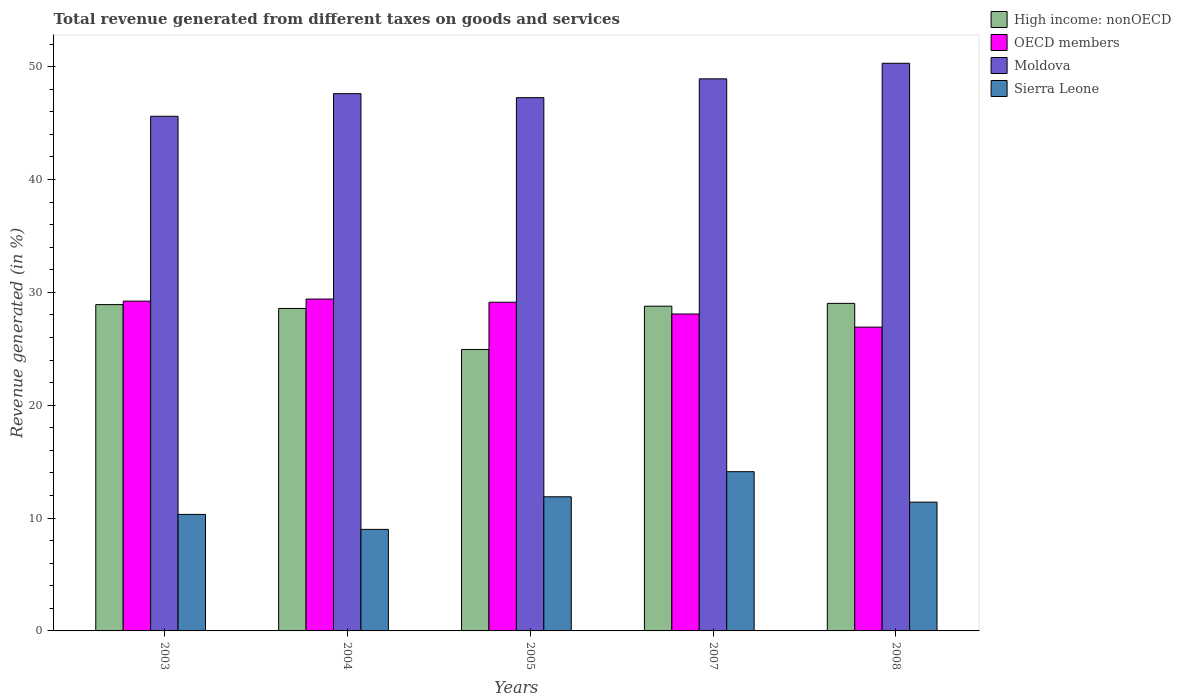How many different coloured bars are there?
Offer a terse response. 4. How many groups of bars are there?
Give a very brief answer. 5. Are the number of bars per tick equal to the number of legend labels?
Provide a short and direct response. Yes. Are the number of bars on each tick of the X-axis equal?
Offer a terse response. Yes. How many bars are there on the 2nd tick from the left?
Provide a succinct answer. 4. How many bars are there on the 2nd tick from the right?
Your answer should be very brief. 4. What is the label of the 3rd group of bars from the left?
Ensure brevity in your answer.  2005. What is the total revenue generated in OECD members in 2003?
Offer a terse response. 29.22. Across all years, what is the maximum total revenue generated in Sierra Leone?
Your answer should be compact. 14.11. Across all years, what is the minimum total revenue generated in Moldova?
Ensure brevity in your answer.  45.61. In which year was the total revenue generated in High income: nonOECD maximum?
Offer a very short reply. 2008. What is the total total revenue generated in Sierra Leone in the graph?
Offer a very short reply. 56.73. What is the difference between the total revenue generated in Moldova in 2005 and that in 2008?
Provide a short and direct response. -3.05. What is the difference between the total revenue generated in Moldova in 2007 and the total revenue generated in Sierra Leone in 2004?
Provide a succinct answer. 39.93. What is the average total revenue generated in OECD members per year?
Ensure brevity in your answer.  28.55. In the year 2003, what is the difference between the total revenue generated in OECD members and total revenue generated in Sierra Leone?
Give a very brief answer. 18.9. In how many years, is the total revenue generated in High income: nonOECD greater than 30 %?
Your response must be concise. 0. What is the ratio of the total revenue generated in Sierra Leone in 2003 to that in 2007?
Provide a short and direct response. 0.73. Is the difference between the total revenue generated in OECD members in 2005 and 2007 greater than the difference between the total revenue generated in Sierra Leone in 2005 and 2007?
Offer a terse response. Yes. What is the difference between the highest and the second highest total revenue generated in Moldova?
Provide a short and direct response. 1.38. What is the difference between the highest and the lowest total revenue generated in High income: nonOECD?
Provide a succinct answer. 4.09. In how many years, is the total revenue generated in OECD members greater than the average total revenue generated in OECD members taken over all years?
Provide a succinct answer. 3. Is it the case that in every year, the sum of the total revenue generated in OECD members and total revenue generated in Moldova is greater than the sum of total revenue generated in Sierra Leone and total revenue generated in High income: nonOECD?
Make the answer very short. Yes. What does the 1st bar from the left in 2005 represents?
Keep it short and to the point. High income: nonOECD. How many bars are there?
Ensure brevity in your answer.  20. Are the values on the major ticks of Y-axis written in scientific E-notation?
Your answer should be very brief. No. Does the graph contain any zero values?
Offer a very short reply. No. How many legend labels are there?
Give a very brief answer. 4. How are the legend labels stacked?
Provide a succinct answer. Vertical. What is the title of the graph?
Your answer should be very brief. Total revenue generated from different taxes on goods and services. Does "Afghanistan" appear as one of the legend labels in the graph?
Your answer should be very brief. No. What is the label or title of the X-axis?
Keep it short and to the point. Years. What is the label or title of the Y-axis?
Your answer should be compact. Revenue generated (in %). What is the Revenue generated (in %) of High income: nonOECD in 2003?
Keep it short and to the point. 28.92. What is the Revenue generated (in %) in OECD members in 2003?
Your answer should be very brief. 29.22. What is the Revenue generated (in %) of Moldova in 2003?
Provide a succinct answer. 45.61. What is the Revenue generated (in %) of Sierra Leone in 2003?
Your answer should be very brief. 10.32. What is the Revenue generated (in %) in High income: nonOECD in 2004?
Provide a succinct answer. 28.58. What is the Revenue generated (in %) of OECD members in 2004?
Ensure brevity in your answer.  29.41. What is the Revenue generated (in %) in Moldova in 2004?
Ensure brevity in your answer.  47.61. What is the Revenue generated (in %) of Sierra Leone in 2004?
Provide a short and direct response. 9. What is the Revenue generated (in %) in High income: nonOECD in 2005?
Ensure brevity in your answer.  24.94. What is the Revenue generated (in %) in OECD members in 2005?
Your answer should be very brief. 29.13. What is the Revenue generated (in %) of Moldova in 2005?
Your answer should be compact. 47.26. What is the Revenue generated (in %) of Sierra Leone in 2005?
Provide a succinct answer. 11.89. What is the Revenue generated (in %) of High income: nonOECD in 2007?
Give a very brief answer. 28.78. What is the Revenue generated (in %) of OECD members in 2007?
Provide a succinct answer. 28.08. What is the Revenue generated (in %) in Moldova in 2007?
Provide a short and direct response. 48.92. What is the Revenue generated (in %) in Sierra Leone in 2007?
Offer a terse response. 14.11. What is the Revenue generated (in %) in High income: nonOECD in 2008?
Offer a terse response. 29.03. What is the Revenue generated (in %) of OECD members in 2008?
Provide a succinct answer. 26.92. What is the Revenue generated (in %) of Moldova in 2008?
Provide a succinct answer. 50.3. What is the Revenue generated (in %) of Sierra Leone in 2008?
Give a very brief answer. 11.41. Across all years, what is the maximum Revenue generated (in %) in High income: nonOECD?
Make the answer very short. 29.03. Across all years, what is the maximum Revenue generated (in %) of OECD members?
Provide a succinct answer. 29.41. Across all years, what is the maximum Revenue generated (in %) of Moldova?
Ensure brevity in your answer.  50.3. Across all years, what is the maximum Revenue generated (in %) of Sierra Leone?
Your answer should be compact. 14.11. Across all years, what is the minimum Revenue generated (in %) in High income: nonOECD?
Give a very brief answer. 24.94. Across all years, what is the minimum Revenue generated (in %) in OECD members?
Provide a succinct answer. 26.92. Across all years, what is the minimum Revenue generated (in %) in Moldova?
Provide a short and direct response. 45.61. Across all years, what is the minimum Revenue generated (in %) of Sierra Leone?
Provide a succinct answer. 9. What is the total Revenue generated (in %) in High income: nonOECD in the graph?
Your answer should be compact. 140.24. What is the total Revenue generated (in %) of OECD members in the graph?
Your answer should be very brief. 142.76. What is the total Revenue generated (in %) of Moldova in the graph?
Give a very brief answer. 239.69. What is the total Revenue generated (in %) in Sierra Leone in the graph?
Your answer should be compact. 56.73. What is the difference between the Revenue generated (in %) in High income: nonOECD in 2003 and that in 2004?
Your answer should be compact. 0.34. What is the difference between the Revenue generated (in %) of OECD members in 2003 and that in 2004?
Offer a very short reply. -0.18. What is the difference between the Revenue generated (in %) of Moldova in 2003 and that in 2004?
Provide a succinct answer. -2. What is the difference between the Revenue generated (in %) of Sierra Leone in 2003 and that in 2004?
Keep it short and to the point. 1.33. What is the difference between the Revenue generated (in %) in High income: nonOECD in 2003 and that in 2005?
Your answer should be very brief. 3.98. What is the difference between the Revenue generated (in %) of OECD members in 2003 and that in 2005?
Offer a very short reply. 0.1. What is the difference between the Revenue generated (in %) in Moldova in 2003 and that in 2005?
Your response must be concise. -1.65. What is the difference between the Revenue generated (in %) of Sierra Leone in 2003 and that in 2005?
Ensure brevity in your answer.  -1.56. What is the difference between the Revenue generated (in %) in High income: nonOECD in 2003 and that in 2007?
Keep it short and to the point. 0.14. What is the difference between the Revenue generated (in %) in OECD members in 2003 and that in 2007?
Offer a terse response. 1.14. What is the difference between the Revenue generated (in %) of Moldova in 2003 and that in 2007?
Give a very brief answer. -3.32. What is the difference between the Revenue generated (in %) of Sierra Leone in 2003 and that in 2007?
Ensure brevity in your answer.  -3.79. What is the difference between the Revenue generated (in %) of High income: nonOECD in 2003 and that in 2008?
Your response must be concise. -0.11. What is the difference between the Revenue generated (in %) of OECD members in 2003 and that in 2008?
Offer a very short reply. 2.3. What is the difference between the Revenue generated (in %) of Moldova in 2003 and that in 2008?
Ensure brevity in your answer.  -4.7. What is the difference between the Revenue generated (in %) of Sierra Leone in 2003 and that in 2008?
Make the answer very short. -1.09. What is the difference between the Revenue generated (in %) of High income: nonOECD in 2004 and that in 2005?
Your response must be concise. 3.63. What is the difference between the Revenue generated (in %) of OECD members in 2004 and that in 2005?
Keep it short and to the point. 0.28. What is the difference between the Revenue generated (in %) in Moldova in 2004 and that in 2005?
Make the answer very short. 0.35. What is the difference between the Revenue generated (in %) of Sierra Leone in 2004 and that in 2005?
Your answer should be compact. -2.89. What is the difference between the Revenue generated (in %) in High income: nonOECD in 2004 and that in 2007?
Provide a succinct answer. -0.2. What is the difference between the Revenue generated (in %) of OECD members in 2004 and that in 2007?
Offer a terse response. 1.32. What is the difference between the Revenue generated (in %) of Moldova in 2004 and that in 2007?
Ensure brevity in your answer.  -1.31. What is the difference between the Revenue generated (in %) in Sierra Leone in 2004 and that in 2007?
Provide a succinct answer. -5.11. What is the difference between the Revenue generated (in %) in High income: nonOECD in 2004 and that in 2008?
Give a very brief answer. -0.45. What is the difference between the Revenue generated (in %) of OECD members in 2004 and that in 2008?
Offer a very short reply. 2.49. What is the difference between the Revenue generated (in %) in Moldova in 2004 and that in 2008?
Offer a very short reply. -2.69. What is the difference between the Revenue generated (in %) of Sierra Leone in 2004 and that in 2008?
Your answer should be compact. -2.41. What is the difference between the Revenue generated (in %) in High income: nonOECD in 2005 and that in 2007?
Offer a terse response. -3.84. What is the difference between the Revenue generated (in %) of OECD members in 2005 and that in 2007?
Your response must be concise. 1.04. What is the difference between the Revenue generated (in %) of Moldova in 2005 and that in 2007?
Your response must be concise. -1.67. What is the difference between the Revenue generated (in %) in Sierra Leone in 2005 and that in 2007?
Give a very brief answer. -2.23. What is the difference between the Revenue generated (in %) of High income: nonOECD in 2005 and that in 2008?
Offer a terse response. -4.09. What is the difference between the Revenue generated (in %) in OECD members in 2005 and that in 2008?
Give a very brief answer. 2.2. What is the difference between the Revenue generated (in %) of Moldova in 2005 and that in 2008?
Give a very brief answer. -3.05. What is the difference between the Revenue generated (in %) of Sierra Leone in 2005 and that in 2008?
Offer a terse response. 0.48. What is the difference between the Revenue generated (in %) in High income: nonOECD in 2007 and that in 2008?
Offer a terse response. -0.25. What is the difference between the Revenue generated (in %) of OECD members in 2007 and that in 2008?
Make the answer very short. 1.16. What is the difference between the Revenue generated (in %) of Moldova in 2007 and that in 2008?
Offer a very short reply. -1.38. What is the difference between the Revenue generated (in %) of Sierra Leone in 2007 and that in 2008?
Provide a succinct answer. 2.7. What is the difference between the Revenue generated (in %) in High income: nonOECD in 2003 and the Revenue generated (in %) in OECD members in 2004?
Offer a terse response. -0.49. What is the difference between the Revenue generated (in %) of High income: nonOECD in 2003 and the Revenue generated (in %) of Moldova in 2004?
Ensure brevity in your answer.  -18.69. What is the difference between the Revenue generated (in %) in High income: nonOECD in 2003 and the Revenue generated (in %) in Sierra Leone in 2004?
Offer a terse response. 19.92. What is the difference between the Revenue generated (in %) in OECD members in 2003 and the Revenue generated (in %) in Moldova in 2004?
Give a very brief answer. -18.39. What is the difference between the Revenue generated (in %) in OECD members in 2003 and the Revenue generated (in %) in Sierra Leone in 2004?
Ensure brevity in your answer.  20.23. What is the difference between the Revenue generated (in %) of Moldova in 2003 and the Revenue generated (in %) of Sierra Leone in 2004?
Give a very brief answer. 36.61. What is the difference between the Revenue generated (in %) in High income: nonOECD in 2003 and the Revenue generated (in %) in OECD members in 2005?
Your answer should be compact. -0.21. What is the difference between the Revenue generated (in %) of High income: nonOECD in 2003 and the Revenue generated (in %) of Moldova in 2005?
Ensure brevity in your answer.  -18.34. What is the difference between the Revenue generated (in %) in High income: nonOECD in 2003 and the Revenue generated (in %) in Sierra Leone in 2005?
Provide a short and direct response. 17.03. What is the difference between the Revenue generated (in %) in OECD members in 2003 and the Revenue generated (in %) in Moldova in 2005?
Your answer should be compact. -18.03. What is the difference between the Revenue generated (in %) of OECD members in 2003 and the Revenue generated (in %) of Sierra Leone in 2005?
Keep it short and to the point. 17.34. What is the difference between the Revenue generated (in %) of Moldova in 2003 and the Revenue generated (in %) of Sierra Leone in 2005?
Keep it short and to the point. 33.72. What is the difference between the Revenue generated (in %) of High income: nonOECD in 2003 and the Revenue generated (in %) of OECD members in 2007?
Provide a succinct answer. 0.83. What is the difference between the Revenue generated (in %) in High income: nonOECD in 2003 and the Revenue generated (in %) in Moldova in 2007?
Keep it short and to the point. -20.01. What is the difference between the Revenue generated (in %) in High income: nonOECD in 2003 and the Revenue generated (in %) in Sierra Leone in 2007?
Your answer should be compact. 14.81. What is the difference between the Revenue generated (in %) in OECD members in 2003 and the Revenue generated (in %) in Moldova in 2007?
Keep it short and to the point. -19.7. What is the difference between the Revenue generated (in %) of OECD members in 2003 and the Revenue generated (in %) of Sierra Leone in 2007?
Give a very brief answer. 15.11. What is the difference between the Revenue generated (in %) of Moldova in 2003 and the Revenue generated (in %) of Sierra Leone in 2007?
Keep it short and to the point. 31.49. What is the difference between the Revenue generated (in %) in High income: nonOECD in 2003 and the Revenue generated (in %) in OECD members in 2008?
Your response must be concise. 1.99. What is the difference between the Revenue generated (in %) of High income: nonOECD in 2003 and the Revenue generated (in %) of Moldova in 2008?
Your answer should be very brief. -21.39. What is the difference between the Revenue generated (in %) in High income: nonOECD in 2003 and the Revenue generated (in %) in Sierra Leone in 2008?
Provide a succinct answer. 17.51. What is the difference between the Revenue generated (in %) in OECD members in 2003 and the Revenue generated (in %) in Moldova in 2008?
Offer a very short reply. -21.08. What is the difference between the Revenue generated (in %) in OECD members in 2003 and the Revenue generated (in %) in Sierra Leone in 2008?
Provide a short and direct response. 17.81. What is the difference between the Revenue generated (in %) in Moldova in 2003 and the Revenue generated (in %) in Sierra Leone in 2008?
Your answer should be very brief. 34.19. What is the difference between the Revenue generated (in %) in High income: nonOECD in 2004 and the Revenue generated (in %) in OECD members in 2005?
Ensure brevity in your answer.  -0.55. What is the difference between the Revenue generated (in %) of High income: nonOECD in 2004 and the Revenue generated (in %) of Moldova in 2005?
Provide a short and direct response. -18.68. What is the difference between the Revenue generated (in %) of High income: nonOECD in 2004 and the Revenue generated (in %) of Sierra Leone in 2005?
Provide a succinct answer. 16.69. What is the difference between the Revenue generated (in %) in OECD members in 2004 and the Revenue generated (in %) in Moldova in 2005?
Your response must be concise. -17.85. What is the difference between the Revenue generated (in %) in OECD members in 2004 and the Revenue generated (in %) in Sierra Leone in 2005?
Keep it short and to the point. 17.52. What is the difference between the Revenue generated (in %) of Moldova in 2004 and the Revenue generated (in %) of Sierra Leone in 2005?
Give a very brief answer. 35.72. What is the difference between the Revenue generated (in %) in High income: nonOECD in 2004 and the Revenue generated (in %) in OECD members in 2007?
Provide a succinct answer. 0.49. What is the difference between the Revenue generated (in %) of High income: nonOECD in 2004 and the Revenue generated (in %) of Moldova in 2007?
Offer a very short reply. -20.35. What is the difference between the Revenue generated (in %) of High income: nonOECD in 2004 and the Revenue generated (in %) of Sierra Leone in 2007?
Your answer should be very brief. 14.46. What is the difference between the Revenue generated (in %) of OECD members in 2004 and the Revenue generated (in %) of Moldova in 2007?
Your answer should be very brief. -19.51. What is the difference between the Revenue generated (in %) of OECD members in 2004 and the Revenue generated (in %) of Sierra Leone in 2007?
Make the answer very short. 15.3. What is the difference between the Revenue generated (in %) in Moldova in 2004 and the Revenue generated (in %) in Sierra Leone in 2007?
Your answer should be compact. 33.5. What is the difference between the Revenue generated (in %) of High income: nonOECD in 2004 and the Revenue generated (in %) of OECD members in 2008?
Ensure brevity in your answer.  1.65. What is the difference between the Revenue generated (in %) of High income: nonOECD in 2004 and the Revenue generated (in %) of Moldova in 2008?
Offer a very short reply. -21.73. What is the difference between the Revenue generated (in %) of High income: nonOECD in 2004 and the Revenue generated (in %) of Sierra Leone in 2008?
Make the answer very short. 17.17. What is the difference between the Revenue generated (in %) of OECD members in 2004 and the Revenue generated (in %) of Moldova in 2008?
Make the answer very short. -20.89. What is the difference between the Revenue generated (in %) of OECD members in 2004 and the Revenue generated (in %) of Sierra Leone in 2008?
Ensure brevity in your answer.  18. What is the difference between the Revenue generated (in %) of Moldova in 2004 and the Revenue generated (in %) of Sierra Leone in 2008?
Your answer should be compact. 36.2. What is the difference between the Revenue generated (in %) in High income: nonOECD in 2005 and the Revenue generated (in %) in OECD members in 2007?
Offer a terse response. -3.14. What is the difference between the Revenue generated (in %) in High income: nonOECD in 2005 and the Revenue generated (in %) in Moldova in 2007?
Your answer should be compact. -23.98. What is the difference between the Revenue generated (in %) in High income: nonOECD in 2005 and the Revenue generated (in %) in Sierra Leone in 2007?
Your answer should be compact. 10.83. What is the difference between the Revenue generated (in %) in OECD members in 2005 and the Revenue generated (in %) in Moldova in 2007?
Keep it short and to the point. -19.8. What is the difference between the Revenue generated (in %) of OECD members in 2005 and the Revenue generated (in %) of Sierra Leone in 2007?
Offer a terse response. 15.01. What is the difference between the Revenue generated (in %) in Moldova in 2005 and the Revenue generated (in %) in Sierra Leone in 2007?
Keep it short and to the point. 33.14. What is the difference between the Revenue generated (in %) in High income: nonOECD in 2005 and the Revenue generated (in %) in OECD members in 2008?
Offer a very short reply. -1.98. What is the difference between the Revenue generated (in %) of High income: nonOECD in 2005 and the Revenue generated (in %) of Moldova in 2008?
Give a very brief answer. -25.36. What is the difference between the Revenue generated (in %) in High income: nonOECD in 2005 and the Revenue generated (in %) in Sierra Leone in 2008?
Your answer should be very brief. 13.53. What is the difference between the Revenue generated (in %) in OECD members in 2005 and the Revenue generated (in %) in Moldova in 2008?
Make the answer very short. -21.18. What is the difference between the Revenue generated (in %) of OECD members in 2005 and the Revenue generated (in %) of Sierra Leone in 2008?
Offer a very short reply. 17.71. What is the difference between the Revenue generated (in %) of Moldova in 2005 and the Revenue generated (in %) of Sierra Leone in 2008?
Your answer should be very brief. 35.84. What is the difference between the Revenue generated (in %) in High income: nonOECD in 2007 and the Revenue generated (in %) in OECD members in 2008?
Ensure brevity in your answer.  1.86. What is the difference between the Revenue generated (in %) of High income: nonOECD in 2007 and the Revenue generated (in %) of Moldova in 2008?
Give a very brief answer. -21.53. What is the difference between the Revenue generated (in %) of High income: nonOECD in 2007 and the Revenue generated (in %) of Sierra Leone in 2008?
Offer a very short reply. 17.37. What is the difference between the Revenue generated (in %) in OECD members in 2007 and the Revenue generated (in %) in Moldova in 2008?
Offer a very short reply. -22.22. What is the difference between the Revenue generated (in %) in OECD members in 2007 and the Revenue generated (in %) in Sierra Leone in 2008?
Provide a short and direct response. 16.67. What is the difference between the Revenue generated (in %) in Moldova in 2007 and the Revenue generated (in %) in Sierra Leone in 2008?
Make the answer very short. 37.51. What is the average Revenue generated (in %) of High income: nonOECD per year?
Make the answer very short. 28.05. What is the average Revenue generated (in %) of OECD members per year?
Make the answer very short. 28.55. What is the average Revenue generated (in %) of Moldova per year?
Keep it short and to the point. 47.94. What is the average Revenue generated (in %) in Sierra Leone per year?
Ensure brevity in your answer.  11.35. In the year 2003, what is the difference between the Revenue generated (in %) of High income: nonOECD and Revenue generated (in %) of OECD members?
Provide a succinct answer. -0.31. In the year 2003, what is the difference between the Revenue generated (in %) in High income: nonOECD and Revenue generated (in %) in Moldova?
Your response must be concise. -16.69. In the year 2003, what is the difference between the Revenue generated (in %) of High income: nonOECD and Revenue generated (in %) of Sierra Leone?
Keep it short and to the point. 18.59. In the year 2003, what is the difference between the Revenue generated (in %) of OECD members and Revenue generated (in %) of Moldova?
Your answer should be very brief. -16.38. In the year 2003, what is the difference between the Revenue generated (in %) in OECD members and Revenue generated (in %) in Sierra Leone?
Give a very brief answer. 18.9. In the year 2003, what is the difference between the Revenue generated (in %) of Moldova and Revenue generated (in %) of Sierra Leone?
Offer a very short reply. 35.28. In the year 2004, what is the difference between the Revenue generated (in %) of High income: nonOECD and Revenue generated (in %) of OECD members?
Provide a succinct answer. -0.83. In the year 2004, what is the difference between the Revenue generated (in %) of High income: nonOECD and Revenue generated (in %) of Moldova?
Ensure brevity in your answer.  -19.03. In the year 2004, what is the difference between the Revenue generated (in %) in High income: nonOECD and Revenue generated (in %) in Sierra Leone?
Offer a terse response. 19.58. In the year 2004, what is the difference between the Revenue generated (in %) of OECD members and Revenue generated (in %) of Moldova?
Your answer should be compact. -18.2. In the year 2004, what is the difference between the Revenue generated (in %) in OECD members and Revenue generated (in %) in Sierra Leone?
Offer a terse response. 20.41. In the year 2004, what is the difference between the Revenue generated (in %) of Moldova and Revenue generated (in %) of Sierra Leone?
Keep it short and to the point. 38.61. In the year 2005, what is the difference between the Revenue generated (in %) in High income: nonOECD and Revenue generated (in %) in OECD members?
Your answer should be compact. -4.18. In the year 2005, what is the difference between the Revenue generated (in %) of High income: nonOECD and Revenue generated (in %) of Moldova?
Give a very brief answer. -22.31. In the year 2005, what is the difference between the Revenue generated (in %) of High income: nonOECD and Revenue generated (in %) of Sierra Leone?
Provide a short and direct response. 13.05. In the year 2005, what is the difference between the Revenue generated (in %) of OECD members and Revenue generated (in %) of Moldova?
Give a very brief answer. -18.13. In the year 2005, what is the difference between the Revenue generated (in %) of OECD members and Revenue generated (in %) of Sierra Leone?
Your answer should be very brief. 17.24. In the year 2005, what is the difference between the Revenue generated (in %) in Moldova and Revenue generated (in %) in Sierra Leone?
Make the answer very short. 35.37. In the year 2007, what is the difference between the Revenue generated (in %) in High income: nonOECD and Revenue generated (in %) in OECD members?
Ensure brevity in your answer.  0.69. In the year 2007, what is the difference between the Revenue generated (in %) in High income: nonOECD and Revenue generated (in %) in Moldova?
Make the answer very short. -20.14. In the year 2007, what is the difference between the Revenue generated (in %) in High income: nonOECD and Revenue generated (in %) in Sierra Leone?
Your response must be concise. 14.67. In the year 2007, what is the difference between the Revenue generated (in %) in OECD members and Revenue generated (in %) in Moldova?
Give a very brief answer. -20.84. In the year 2007, what is the difference between the Revenue generated (in %) in OECD members and Revenue generated (in %) in Sierra Leone?
Make the answer very short. 13.97. In the year 2007, what is the difference between the Revenue generated (in %) of Moldova and Revenue generated (in %) of Sierra Leone?
Ensure brevity in your answer.  34.81. In the year 2008, what is the difference between the Revenue generated (in %) of High income: nonOECD and Revenue generated (in %) of OECD members?
Ensure brevity in your answer.  2.1. In the year 2008, what is the difference between the Revenue generated (in %) in High income: nonOECD and Revenue generated (in %) in Moldova?
Make the answer very short. -21.28. In the year 2008, what is the difference between the Revenue generated (in %) of High income: nonOECD and Revenue generated (in %) of Sierra Leone?
Give a very brief answer. 17.62. In the year 2008, what is the difference between the Revenue generated (in %) of OECD members and Revenue generated (in %) of Moldova?
Provide a succinct answer. -23.38. In the year 2008, what is the difference between the Revenue generated (in %) in OECD members and Revenue generated (in %) in Sierra Leone?
Offer a very short reply. 15.51. In the year 2008, what is the difference between the Revenue generated (in %) of Moldova and Revenue generated (in %) of Sierra Leone?
Provide a succinct answer. 38.89. What is the ratio of the Revenue generated (in %) in High income: nonOECD in 2003 to that in 2004?
Provide a short and direct response. 1.01. What is the ratio of the Revenue generated (in %) of Moldova in 2003 to that in 2004?
Make the answer very short. 0.96. What is the ratio of the Revenue generated (in %) in Sierra Leone in 2003 to that in 2004?
Keep it short and to the point. 1.15. What is the ratio of the Revenue generated (in %) of High income: nonOECD in 2003 to that in 2005?
Your answer should be compact. 1.16. What is the ratio of the Revenue generated (in %) of Moldova in 2003 to that in 2005?
Provide a succinct answer. 0.97. What is the ratio of the Revenue generated (in %) in Sierra Leone in 2003 to that in 2005?
Offer a very short reply. 0.87. What is the ratio of the Revenue generated (in %) of OECD members in 2003 to that in 2007?
Provide a short and direct response. 1.04. What is the ratio of the Revenue generated (in %) in Moldova in 2003 to that in 2007?
Ensure brevity in your answer.  0.93. What is the ratio of the Revenue generated (in %) of Sierra Leone in 2003 to that in 2007?
Your answer should be very brief. 0.73. What is the ratio of the Revenue generated (in %) in High income: nonOECD in 2003 to that in 2008?
Give a very brief answer. 1. What is the ratio of the Revenue generated (in %) in OECD members in 2003 to that in 2008?
Your answer should be very brief. 1.09. What is the ratio of the Revenue generated (in %) in Moldova in 2003 to that in 2008?
Make the answer very short. 0.91. What is the ratio of the Revenue generated (in %) in Sierra Leone in 2003 to that in 2008?
Your answer should be very brief. 0.9. What is the ratio of the Revenue generated (in %) of High income: nonOECD in 2004 to that in 2005?
Offer a terse response. 1.15. What is the ratio of the Revenue generated (in %) of OECD members in 2004 to that in 2005?
Make the answer very short. 1.01. What is the ratio of the Revenue generated (in %) of Moldova in 2004 to that in 2005?
Make the answer very short. 1.01. What is the ratio of the Revenue generated (in %) of Sierra Leone in 2004 to that in 2005?
Your answer should be compact. 0.76. What is the ratio of the Revenue generated (in %) of OECD members in 2004 to that in 2007?
Make the answer very short. 1.05. What is the ratio of the Revenue generated (in %) of Moldova in 2004 to that in 2007?
Ensure brevity in your answer.  0.97. What is the ratio of the Revenue generated (in %) of Sierra Leone in 2004 to that in 2007?
Give a very brief answer. 0.64. What is the ratio of the Revenue generated (in %) in High income: nonOECD in 2004 to that in 2008?
Offer a very short reply. 0.98. What is the ratio of the Revenue generated (in %) of OECD members in 2004 to that in 2008?
Offer a terse response. 1.09. What is the ratio of the Revenue generated (in %) in Moldova in 2004 to that in 2008?
Your response must be concise. 0.95. What is the ratio of the Revenue generated (in %) of Sierra Leone in 2004 to that in 2008?
Your answer should be very brief. 0.79. What is the ratio of the Revenue generated (in %) of High income: nonOECD in 2005 to that in 2007?
Offer a terse response. 0.87. What is the ratio of the Revenue generated (in %) of OECD members in 2005 to that in 2007?
Give a very brief answer. 1.04. What is the ratio of the Revenue generated (in %) in Moldova in 2005 to that in 2007?
Provide a succinct answer. 0.97. What is the ratio of the Revenue generated (in %) of Sierra Leone in 2005 to that in 2007?
Keep it short and to the point. 0.84. What is the ratio of the Revenue generated (in %) of High income: nonOECD in 2005 to that in 2008?
Your answer should be compact. 0.86. What is the ratio of the Revenue generated (in %) of OECD members in 2005 to that in 2008?
Make the answer very short. 1.08. What is the ratio of the Revenue generated (in %) of Moldova in 2005 to that in 2008?
Your response must be concise. 0.94. What is the ratio of the Revenue generated (in %) in Sierra Leone in 2005 to that in 2008?
Your answer should be compact. 1.04. What is the ratio of the Revenue generated (in %) in High income: nonOECD in 2007 to that in 2008?
Keep it short and to the point. 0.99. What is the ratio of the Revenue generated (in %) of OECD members in 2007 to that in 2008?
Your answer should be compact. 1.04. What is the ratio of the Revenue generated (in %) of Moldova in 2007 to that in 2008?
Keep it short and to the point. 0.97. What is the ratio of the Revenue generated (in %) in Sierra Leone in 2007 to that in 2008?
Offer a very short reply. 1.24. What is the difference between the highest and the second highest Revenue generated (in %) of High income: nonOECD?
Offer a terse response. 0.11. What is the difference between the highest and the second highest Revenue generated (in %) of OECD members?
Make the answer very short. 0.18. What is the difference between the highest and the second highest Revenue generated (in %) in Moldova?
Make the answer very short. 1.38. What is the difference between the highest and the second highest Revenue generated (in %) of Sierra Leone?
Offer a very short reply. 2.23. What is the difference between the highest and the lowest Revenue generated (in %) in High income: nonOECD?
Offer a terse response. 4.09. What is the difference between the highest and the lowest Revenue generated (in %) of OECD members?
Your answer should be very brief. 2.49. What is the difference between the highest and the lowest Revenue generated (in %) in Moldova?
Provide a short and direct response. 4.7. What is the difference between the highest and the lowest Revenue generated (in %) in Sierra Leone?
Provide a short and direct response. 5.11. 